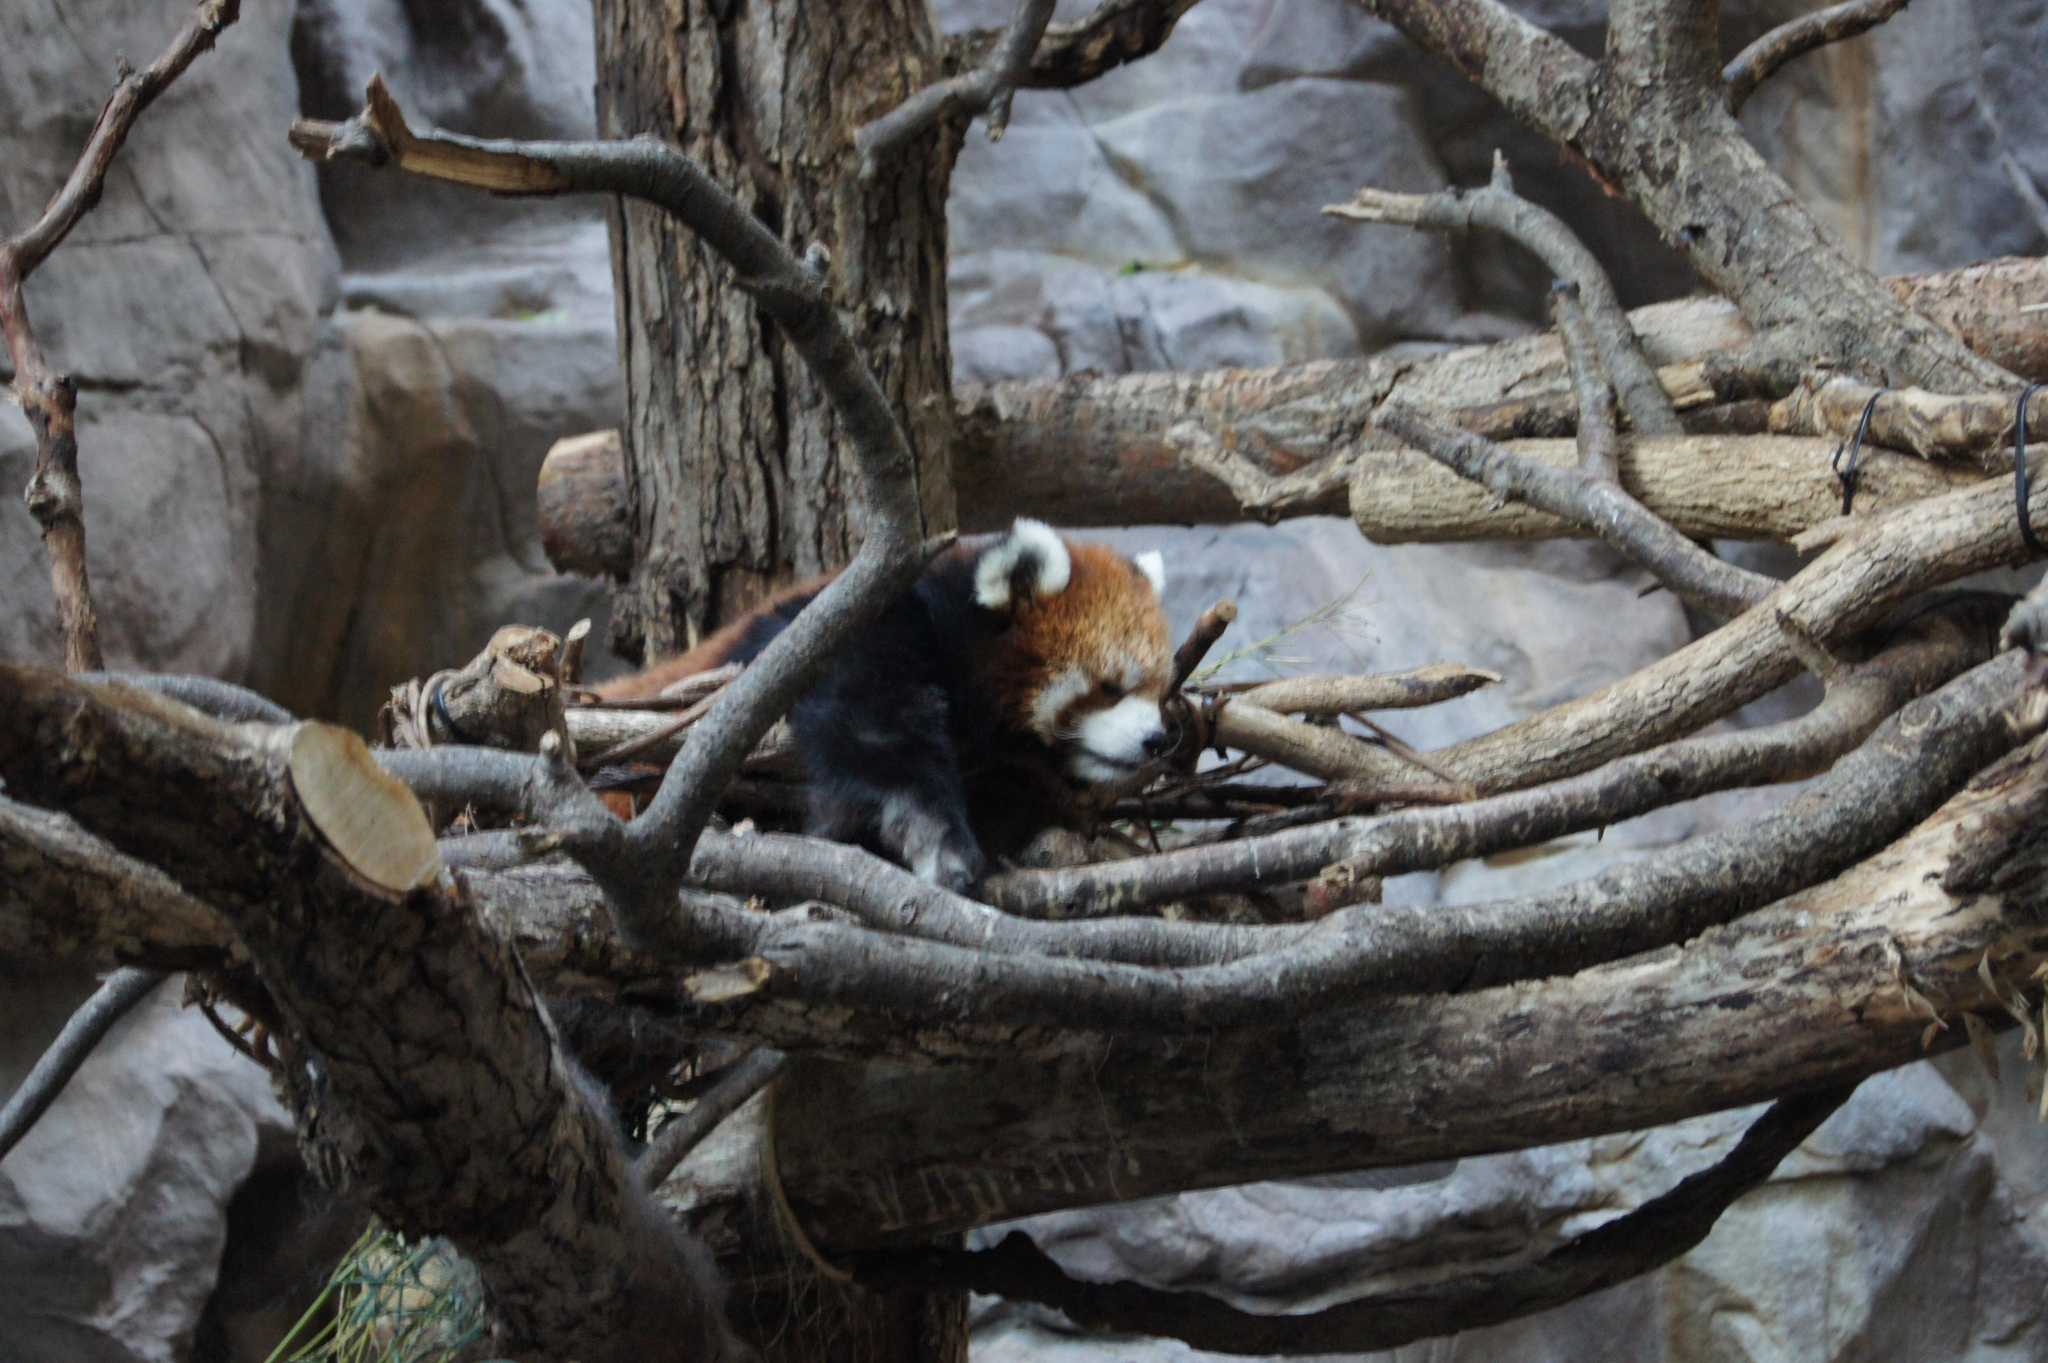What type of animal is in the image? The animal in the image has not been specified, but it has white, brown, and black colors. Can you describe the animal's location in the image? The animal is between wooden branches in the image. What can be seen in the background of the image? There is a rock visible in the background of the image. How much money is the animal holding in the image? There is no indication of money or any financial transaction in the image; it features an animal between wooden branches with a rock visible in the background. 